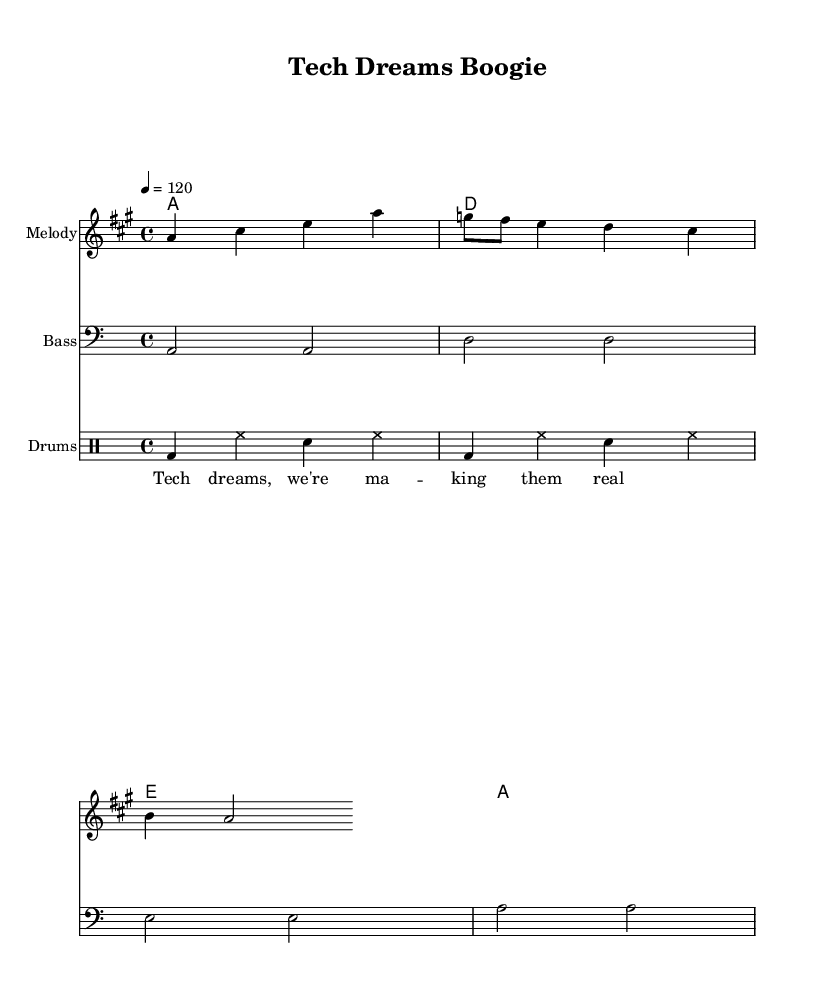What is the key signature of this music? The key signature is A major, which has three sharps (F#, C#, and G#). This can be determined by looking at the key indication at the beginning of the score.
Answer: A major What is the time signature of the piece? The time signature is 4/4, indicating that there are four beats in each measure and a quarter note receives one beat. This is indicated at the start of the music sheet.
Answer: 4/4 What is the tempo marking given? The tempo marking is 120 beats per minute, which is indicated above the staff at the beginning of the music.
Answer: 120 How many measures are in the melody? The melody consists of eight measures, which can be counted by the number of bar lines present in the melody staff.
Answer: 8 Which instrument has the bass line? The bass line is played by the bass instrument, as indicated by the instrument name labeled on the staff containing the bass line.
Answer: Bass What kind of music is this? This music is a disco anthem, which can be inferred from the upbeat tempo and the groove established by the bass and drum parts, common in disco music.
Answer: Disco What is the lyrical theme of the song? The lyrical theme revolves around making dreams a reality, as indicated by the lyrics "Tech dreams, we're ma -- king them real".
Answer: Making dreams real 